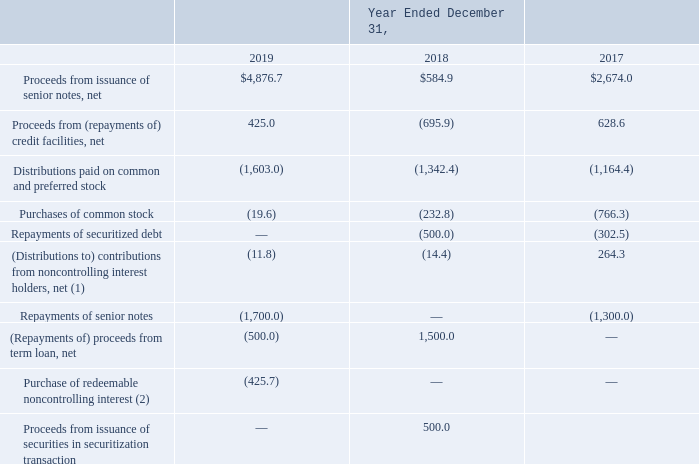Cash Flows from Financing Activities
Our significant financing activities were as follows (in millions):
(1) 2017 contributions primarily relate to the funding of the FPS Acquisition.
(2) In the fourth quarter of 2018, two of our minority holders in India delivered notice of exercise of their put options with respect to certain shares in our Indian subsidiary, ATC TIPL. During the year ended December 31, 2019, we completed the redemption of the put shares for total consideration of INR 29.4 billion ($425.7 million at the date of redemption).
Senior Notes
Repayments of Senior Notes
Repayment of 3.40% Senior Notes—On the February 15, 2019 maturity date, we repaid $1.0 billion aggregate principal amount of the 3.40% Notes. The 3.40% Notes were repaid with borrowings from the 2019 Multicurrency Credit Facility and the 2019 Credit Facility. Upon completion of the repayment, none of the 3.40% Notes remained outstanding.
Repayment of 5.050% Senior Notes—On April 22, 2019, we redeemed all of the $700.0 million aggregate principal amount of the 5.050% Notes at a price equal to 103.0050% of the principal amount, plus accrued and unpaid interest up to, but excluding April 22, 2019, for an aggregate redemption price of $726.0 million, including $5.0 million in accrued and unpaid interest. We recorded a loss on retirement of long-term obligations of $22.1 million, which includes prepayment consideration of $21.0 million and the associated unamortized discount and deferred financing costs. The redemption was funded with borrowings from the 2019 Credit Facility and cash on hand. Upon completion of the repayment, none of the 5.050% Notes remained outstanding.
Repayment of 5.900% Senior Notes—On January 15, 2020, we redeemed all of the $500.0 million aggregate principal amount of 5.900% senior unsecured notes due 2021 (the “5.900% Notes”) at a price equal to 106.7090% of the principal amount, plus accrued and unpaid interest up to, but excluding January 15, 2020, for an aggregate redemption price of $539.6 million, including $6.1 million in accrued and unpaid interest. We recorded a loss on retirement of long-term obligations of $34.6 million, which includes prepayment consideration of $33.5 million and the associated unamortized discount and deferred financing costs. The redemption was funded with borrowings from the 2019 Credit Facility and cash on hand. Upon completion of the repayment, none of the 5.900% Notes remained outstanding.
What were the net Proceeds from issuance of senior notes in 2019?
Answer scale should be: million. $4,876.7. What were the net Proceeds from (repayments of) credit facilities in 2018?
Answer scale should be: million. (695.9). What were the Distributions paid on common and preferred stock in 2017?
Answer scale should be: million. (1,164.4). What was the change in Purchases of common stock between 2018 and 2019?
Answer scale should be: million. -19.6-(-232.8)
Answer: 213.2. What was the change in net (Distributions to) contributions from noncontrolling interest holders between 2017 and 2018?
Answer scale should be: million. -14.4-264.3
Answer: -278.7. What was the percentage change in the net Proceeds from issuance of senior notes between 2018 and 2019?
Answer scale should be: percent. ($4,876.7-$584.9)/$584.9
Answer: 733.77. 